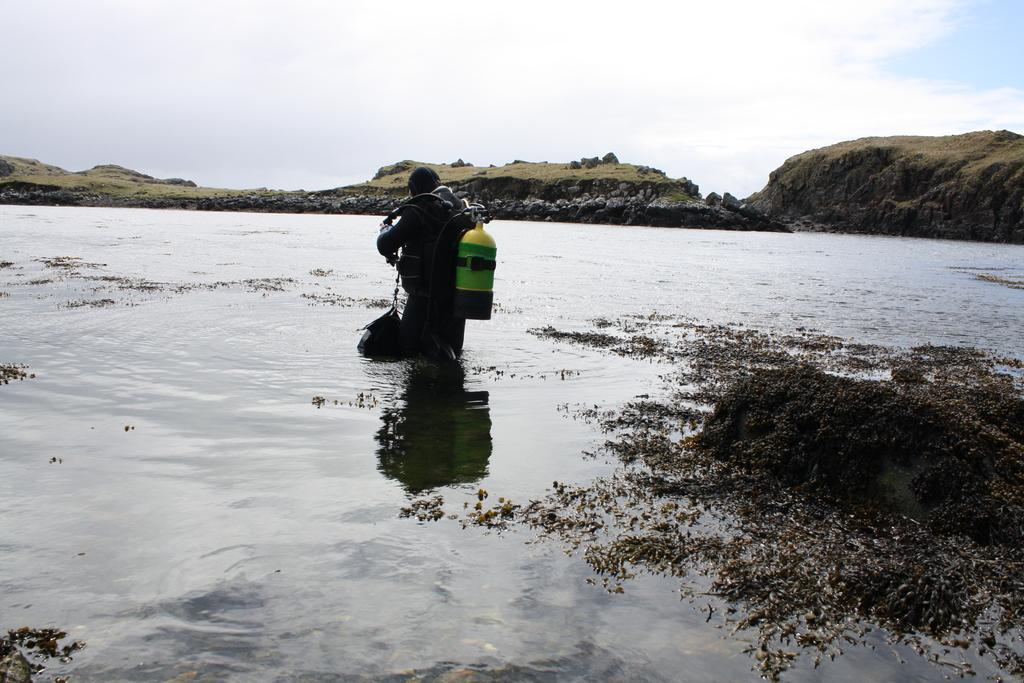What is the person in the image doing? The person is walking in the water. What is the person wearing on his back? The person is wearing a cylinder on his back. What can be seen in the background of the image? There are hills, plants, water, and the sky visible in the background of the image. What is the condition of the sky in the image? The sky is visible in the background of the image, and clouds are present. What type of cart is being used by the monkey in the image? There is no monkey or cart present in the image. How does the person wash the clothes in the image? There is no indication of clothes or washing in the image; the person is simply walking in the water with a cylinder on his back. 